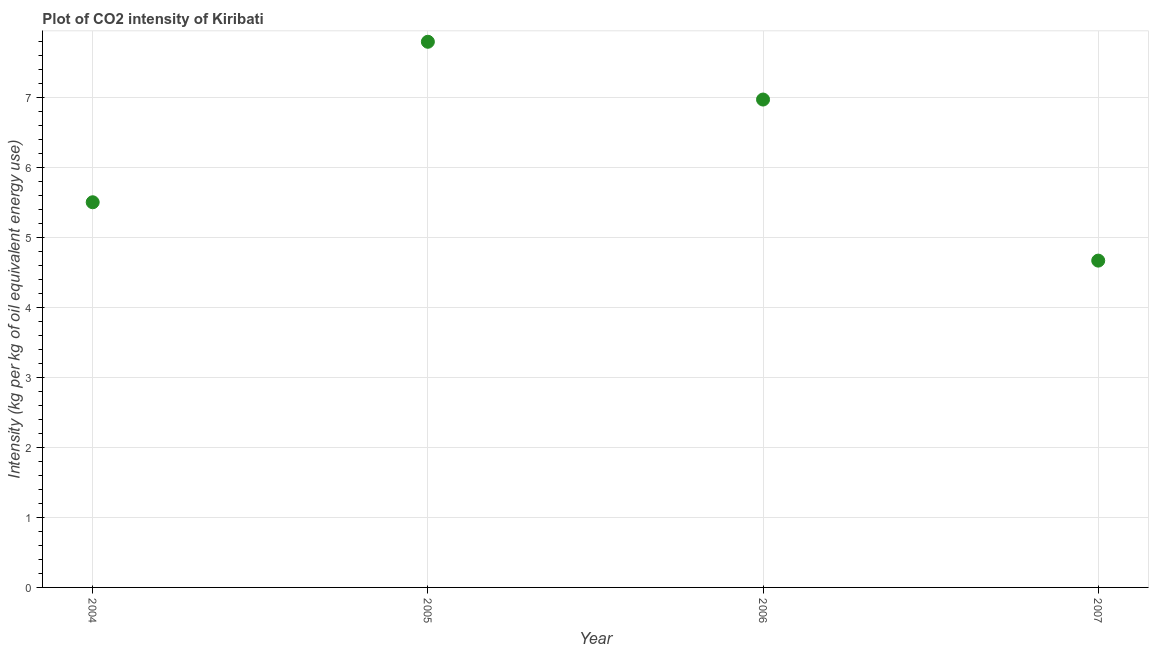What is the co2 intensity in 2004?
Keep it short and to the point. 5.5. Across all years, what is the maximum co2 intensity?
Keep it short and to the point. 7.79. Across all years, what is the minimum co2 intensity?
Your answer should be very brief. 4.67. What is the sum of the co2 intensity?
Your answer should be compact. 24.93. What is the difference between the co2 intensity in 2006 and 2007?
Provide a succinct answer. 2.3. What is the average co2 intensity per year?
Your answer should be very brief. 6.23. What is the median co2 intensity?
Your response must be concise. 6.23. In how many years, is the co2 intensity greater than 4.8 kg?
Offer a terse response. 3. Do a majority of the years between 2007 and 2006 (inclusive) have co2 intensity greater than 3.4 kg?
Keep it short and to the point. No. What is the ratio of the co2 intensity in 2004 to that in 2006?
Ensure brevity in your answer.  0.79. What is the difference between the highest and the second highest co2 intensity?
Provide a succinct answer. 0.83. Is the sum of the co2 intensity in 2006 and 2007 greater than the maximum co2 intensity across all years?
Ensure brevity in your answer.  Yes. What is the difference between the highest and the lowest co2 intensity?
Ensure brevity in your answer.  3.13. In how many years, is the co2 intensity greater than the average co2 intensity taken over all years?
Your answer should be compact. 2. How many dotlines are there?
Offer a terse response. 1. What is the difference between two consecutive major ticks on the Y-axis?
Offer a very short reply. 1. Are the values on the major ticks of Y-axis written in scientific E-notation?
Provide a succinct answer. No. Does the graph contain grids?
Provide a short and direct response. Yes. What is the title of the graph?
Offer a very short reply. Plot of CO2 intensity of Kiribati. What is the label or title of the Y-axis?
Ensure brevity in your answer.  Intensity (kg per kg of oil equivalent energy use). What is the Intensity (kg per kg of oil equivalent energy use) in 2004?
Offer a very short reply. 5.5. What is the Intensity (kg per kg of oil equivalent energy use) in 2005?
Keep it short and to the point. 7.79. What is the Intensity (kg per kg of oil equivalent energy use) in 2006?
Your answer should be very brief. 6.97. What is the Intensity (kg per kg of oil equivalent energy use) in 2007?
Offer a terse response. 4.67. What is the difference between the Intensity (kg per kg of oil equivalent energy use) in 2004 and 2005?
Your answer should be very brief. -2.29. What is the difference between the Intensity (kg per kg of oil equivalent energy use) in 2004 and 2006?
Your answer should be compact. -1.47. What is the difference between the Intensity (kg per kg of oil equivalent energy use) in 2004 and 2007?
Provide a short and direct response. 0.83. What is the difference between the Intensity (kg per kg of oil equivalent energy use) in 2005 and 2006?
Make the answer very short. 0.83. What is the difference between the Intensity (kg per kg of oil equivalent energy use) in 2005 and 2007?
Your answer should be very brief. 3.13. What is the difference between the Intensity (kg per kg of oil equivalent energy use) in 2006 and 2007?
Ensure brevity in your answer.  2.3. What is the ratio of the Intensity (kg per kg of oil equivalent energy use) in 2004 to that in 2005?
Your answer should be very brief. 0.71. What is the ratio of the Intensity (kg per kg of oil equivalent energy use) in 2004 to that in 2006?
Keep it short and to the point. 0.79. What is the ratio of the Intensity (kg per kg of oil equivalent energy use) in 2004 to that in 2007?
Provide a short and direct response. 1.18. What is the ratio of the Intensity (kg per kg of oil equivalent energy use) in 2005 to that in 2006?
Your answer should be very brief. 1.12. What is the ratio of the Intensity (kg per kg of oil equivalent energy use) in 2005 to that in 2007?
Keep it short and to the point. 1.67. What is the ratio of the Intensity (kg per kg of oil equivalent energy use) in 2006 to that in 2007?
Your answer should be compact. 1.49. 